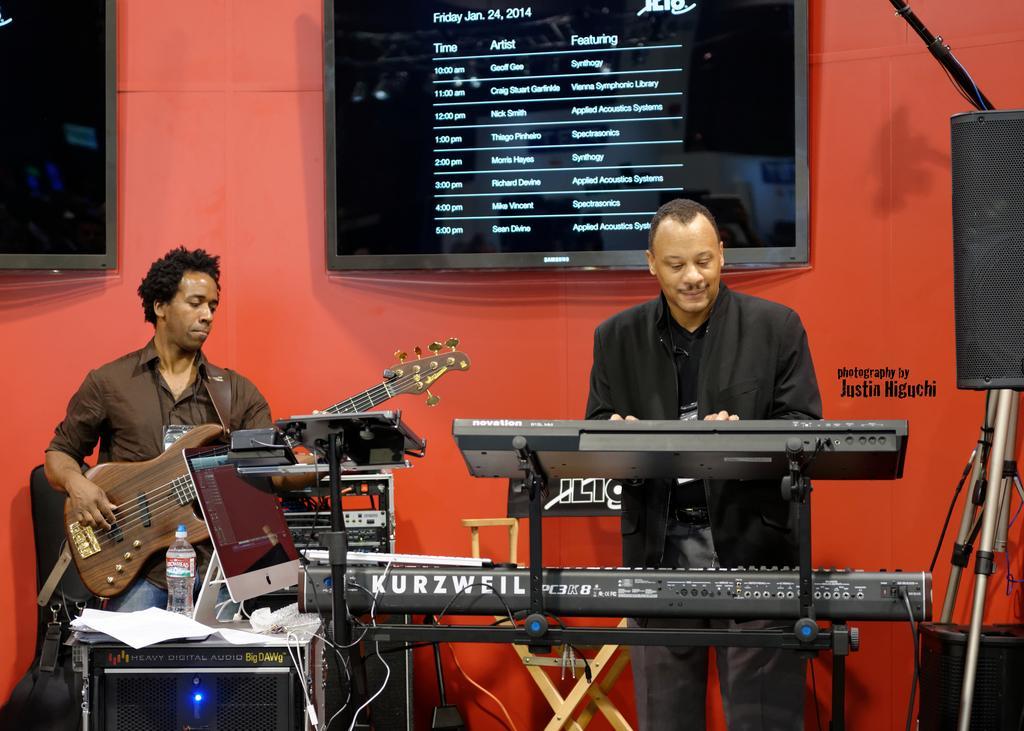In one or two sentences, can you explain what this image depicts? In this image I can see two men are playing musical instruments. In the background I can see a screen with a list. 